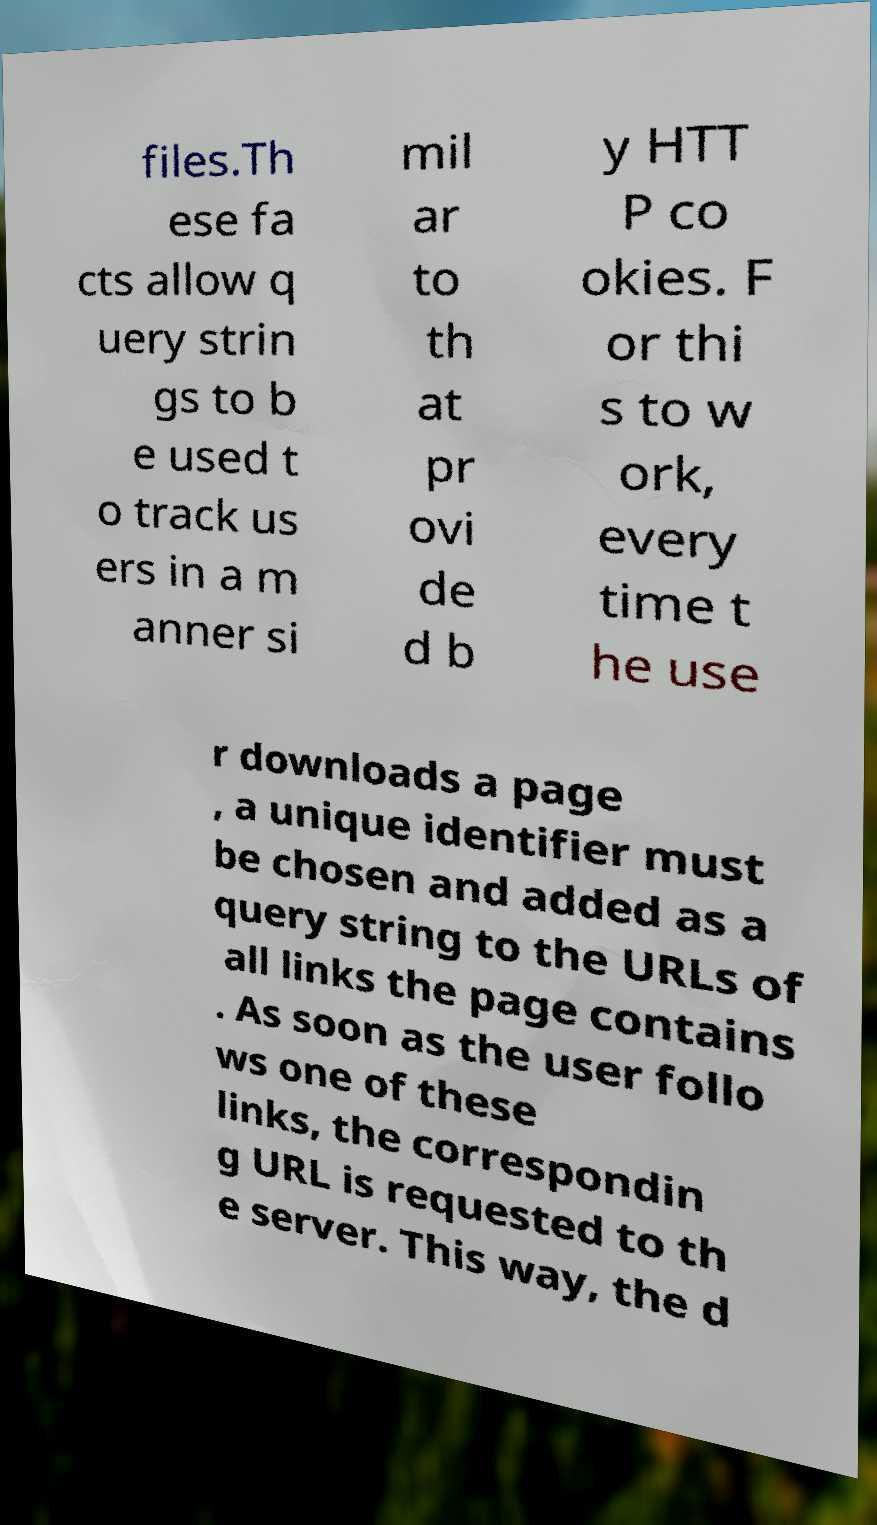Please read and relay the text visible in this image. What does it say? files.Th ese fa cts allow q uery strin gs to b e used t o track us ers in a m anner si mil ar to th at pr ovi de d b y HTT P co okies. F or thi s to w ork, every time t he use r downloads a page , a unique identifier must be chosen and added as a query string to the URLs of all links the page contains . As soon as the user follo ws one of these links, the correspondin g URL is requested to th e server. This way, the d 